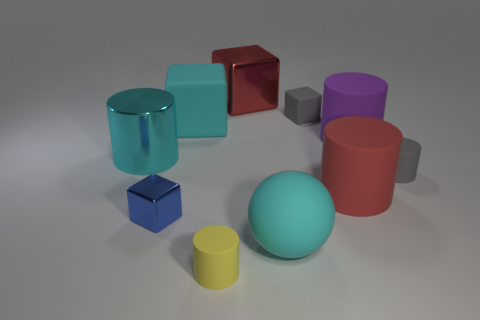Subtract 1 cylinders. How many cylinders are left? 4 Subtract all large red rubber cylinders. How many cylinders are left? 4 Subtract all purple cylinders. How many cylinders are left? 4 Subtract all blue cylinders. Subtract all brown spheres. How many cylinders are left? 5 Subtract all balls. How many objects are left? 9 Subtract all purple cylinders. Subtract all large cyan metal cylinders. How many objects are left? 8 Add 3 large cubes. How many large cubes are left? 5 Add 9 large cyan metallic cylinders. How many large cyan metallic cylinders exist? 10 Subtract 1 purple cylinders. How many objects are left? 9 